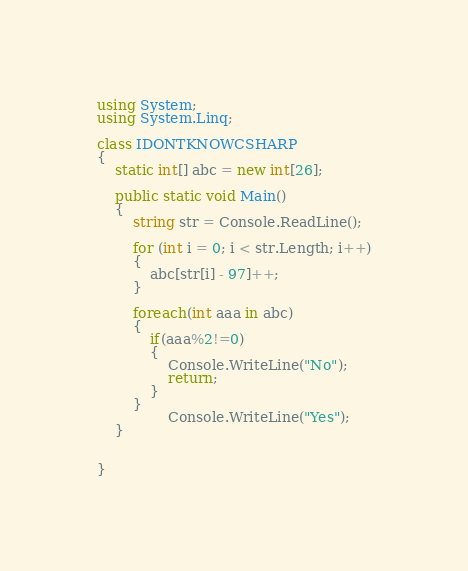Convert code to text. <code><loc_0><loc_0><loc_500><loc_500><_C#_>
using System;
using System.Linq;

class IDONTKNOWCSHARP
{
    static int[] abc = new int[26];

    public static void Main()
    {
        string str = Console.ReadLine();

        for (int i = 0; i < str.Length; i++)
        {
            abc[str[i] - 97]++;
        }

        foreach(int aaa in abc)
        {
            if(aaa%2!=0)
            {
                Console.WriteLine("No");
                return;
            }
        }
                Console.WriteLine("Yes");
    }


}</code> 